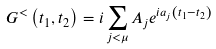<formula> <loc_0><loc_0><loc_500><loc_500>G ^ { < } \left ( t _ { 1 } , t _ { 2 } \right ) = i \sum _ { j < \mu } A _ { j } e ^ { i a _ { j } \left ( t _ { 1 } - t _ { 2 } \right ) }</formula> 